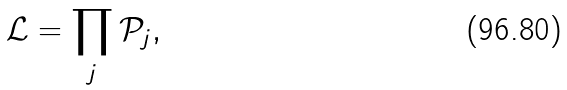<formula> <loc_0><loc_0><loc_500><loc_500>\mathcal { L } = \prod _ { j } \mathcal { P } _ { j } ,</formula> 